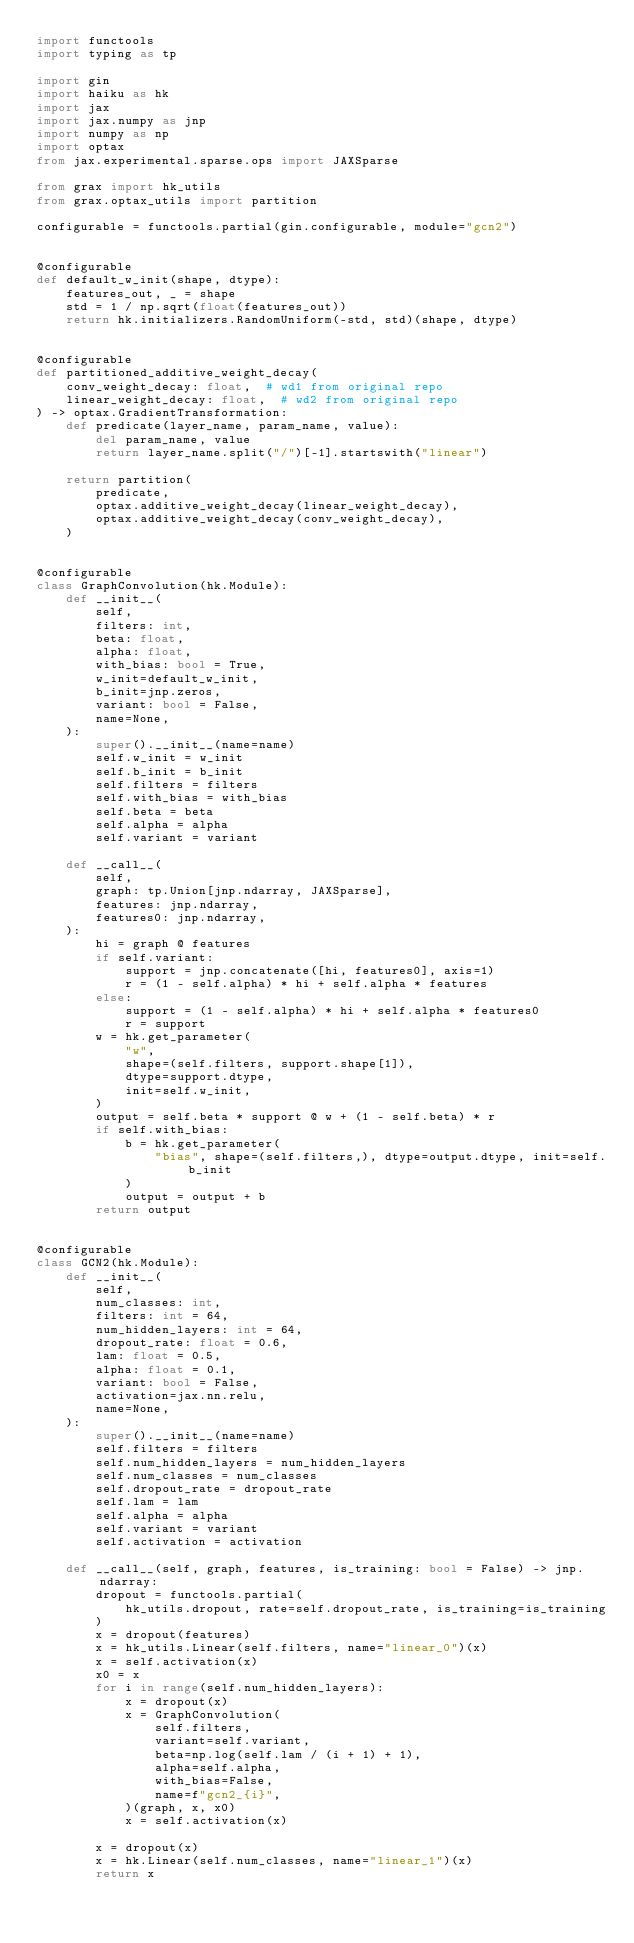<code> <loc_0><loc_0><loc_500><loc_500><_Python_>import functools
import typing as tp

import gin
import haiku as hk
import jax
import jax.numpy as jnp
import numpy as np
import optax
from jax.experimental.sparse.ops import JAXSparse

from grax import hk_utils
from grax.optax_utils import partition

configurable = functools.partial(gin.configurable, module="gcn2")


@configurable
def default_w_init(shape, dtype):
    features_out, _ = shape
    std = 1 / np.sqrt(float(features_out))
    return hk.initializers.RandomUniform(-std, std)(shape, dtype)


@configurable
def partitioned_additive_weight_decay(
    conv_weight_decay: float,  # wd1 from original repo
    linear_weight_decay: float,  # wd2 from original repo
) -> optax.GradientTransformation:
    def predicate(layer_name, param_name, value):
        del param_name, value
        return layer_name.split("/")[-1].startswith("linear")

    return partition(
        predicate,
        optax.additive_weight_decay(linear_weight_decay),
        optax.additive_weight_decay(conv_weight_decay),
    )


@configurable
class GraphConvolution(hk.Module):
    def __init__(
        self,
        filters: int,
        beta: float,
        alpha: float,
        with_bias: bool = True,
        w_init=default_w_init,
        b_init=jnp.zeros,
        variant: bool = False,
        name=None,
    ):
        super().__init__(name=name)
        self.w_init = w_init
        self.b_init = b_init
        self.filters = filters
        self.with_bias = with_bias
        self.beta = beta
        self.alpha = alpha
        self.variant = variant

    def __call__(
        self,
        graph: tp.Union[jnp.ndarray, JAXSparse],
        features: jnp.ndarray,
        features0: jnp.ndarray,
    ):
        hi = graph @ features
        if self.variant:
            support = jnp.concatenate([hi, features0], axis=1)
            r = (1 - self.alpha) * hi + self.alpha * features
        else:
            support = (1 - self.alpha) * hi + self.alpha * features0
            r = support
        w = hk.get_parameter(
            "w",
            shape=(self.filters, support.shape[1]),
            dtype=support.dtype,
            init=self.w_init,
        )
        output = self.beta * support @ w + (1 - self.beta) * r
        if self.with_bias:
            b = hk.get_parameter(
                "bias", shape=(self.filters,), dtype=output.dtype, init=self.b_init
            )
            output = output + b
        return output


@configurable
class GCN2(hk.Module):
    def __init__(
        self,
        num_classes: int,
        filters: int = 64,
        num_hidden_layers: int = 64,
        dropout_rate: float = 0.6,
        lam: float = 0.5,
        alpha: float = 0.1,
        variant: bool = False,
        activation=jax.nn.relu,
        name=None,
    ):
        super().__init__(name=name)
        self.filters = filters
        self.num_hidden_layers = num_hidden_layers
        self.num_classes = num_classes
        self.dropout_rate = dropout_rate
        self.lam = lam
        self.alpha = alpha
        self.variant = variant
        self.activation = activation

    def __call__(self, graph, features, is_training: bool = False) -> jnp.ndarray:
        dropout = functools.partial(
            hk_utils.dropout, rate=self.dropout_rate, is_training=is_training
        )
        x = dropout(features)
        x = hk_utils.Linear(self.filters, name="linear_0")(x)
        x = self.activation(x)
        x0 = x
        for i in range(self.num_hidden_layers):
            x = dropout(x)
            x = GraphConvolution(
                self.filters,
                variant=self.variant,
                beta=np.log(self.lam / (i + 1) + 1),
                alpha=self.alpha,
                with_bias=False,
                name=f"gcn2_{i}",
            )(graph, x, x0)
            x = self.activation(x)

        x = dropout(x)
        x = hk.Linear(self.num_classes, name="linear_1")(x)
        return x
</code> 